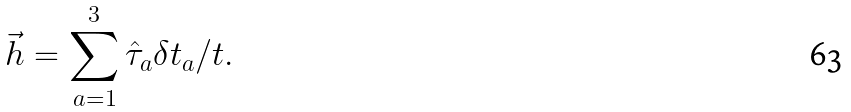Convert formula to latex. <formula><loc_0><loc_0><loc_500><loc_500>\vec { h } = \sum _ { a = 1 } ^ { 3 } \hat { \tau } _ { a } \delta t _ { a } / t .</formula> 